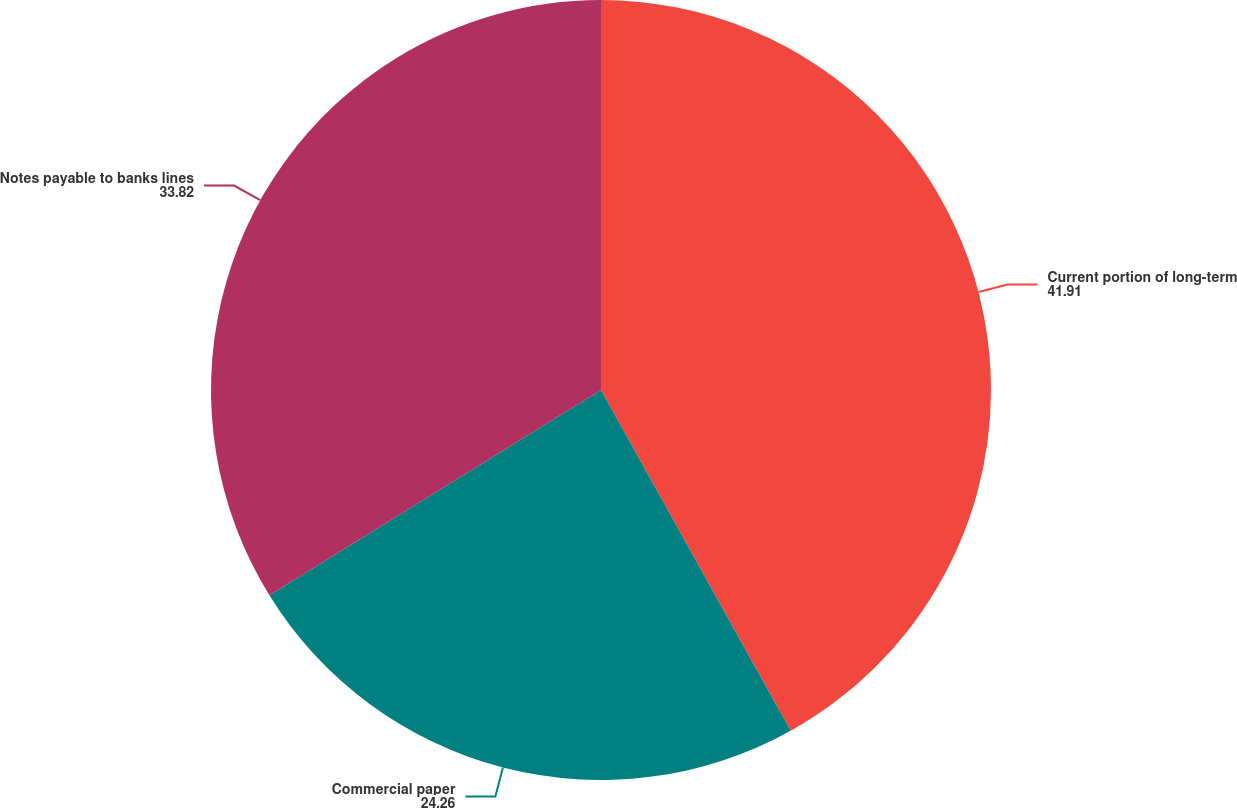Convert chart to OTSL. <chart><loc_0><loc_0><loc_500><loc_500><pie_chart><fcel>Current portion of long-term<fcel>Commercial paper<fcel>Notes payable to banks lines<nl><fcel>41.91%<fcel>24.26%<fcel>33.82%<nl></chart> 